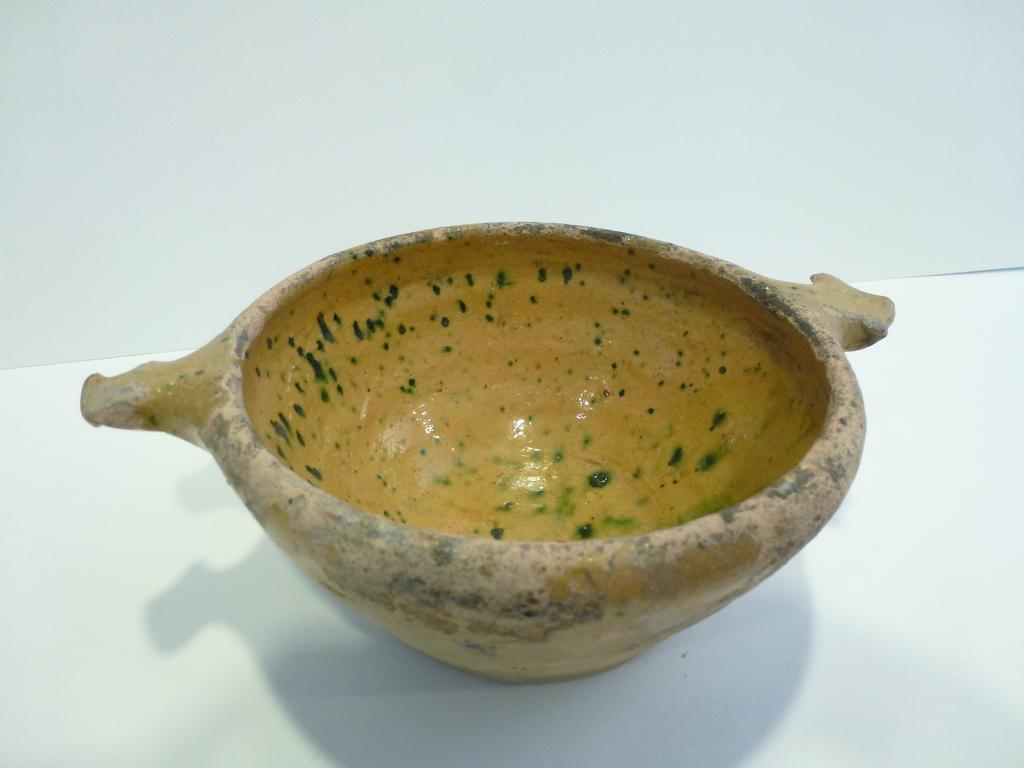Can you describe this image briefly? In this picture we can see a bowl. 